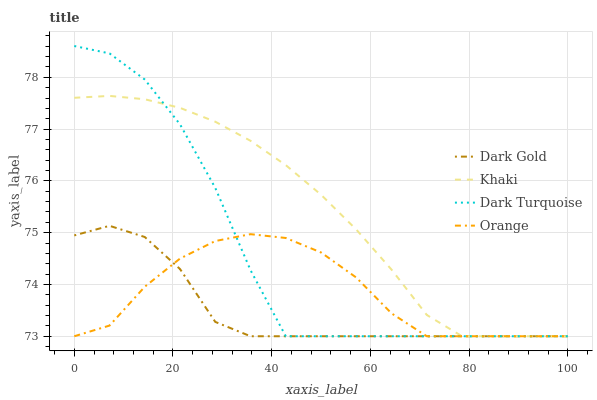Does Dark Gold have the minimum area under the curve?
Answer yes or no. Yes. Does Khaki have the maximum area under the curve?
Answer yes or no. Yes. Does Dark Turquoise have the minimum area under the curve?
Answer yes or no. No. Does Dark Turquoise have the maximum area under the curve?
Answer yes or no. No. Is Khaki the smoothest?
Answer yes or no. Yes. Is Dark Turquoise the roughest?
Answer yes or no. Yes. Is Dark Turquoise the smoothest?
Answer yes or no. No. Is Khaki the roughest?
Answer yes or no. No. Does Khaki have the highest value?
Answer yes or no. No. 